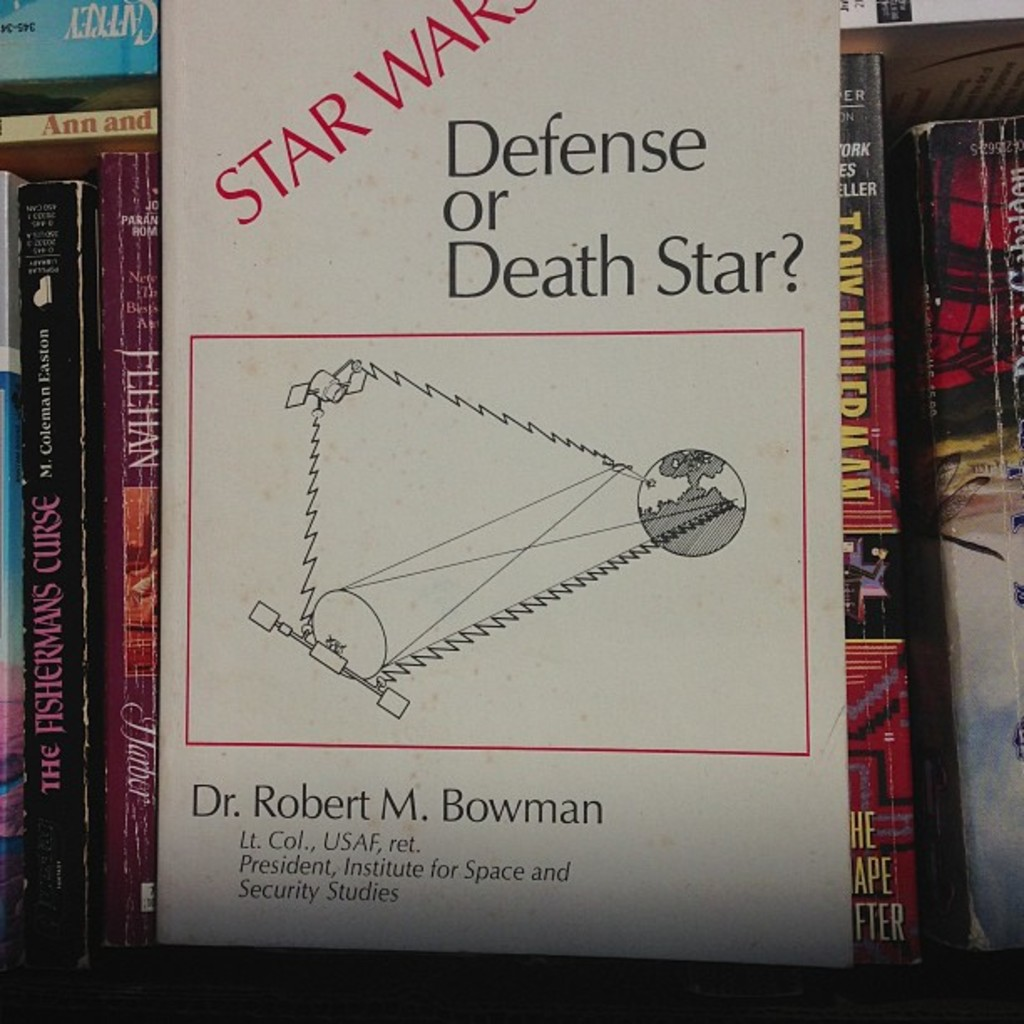Can you analyze how this book might relate the topic of the Death Star to real security concerns? Considering the title and cover imagery, the book likely explores the conceptual idea of the Death Star — a massively destructive weapon from the Star Wars films — in comparison to modern military and aerospace strategy. Dr. Bowman may discuss theoretical approaches to space security and defense mechanisms, drawing parallels to the fictional superweapon to underline serious implications of warfare in space and the necessity of space policy that addresses both theoretical and real threats. 